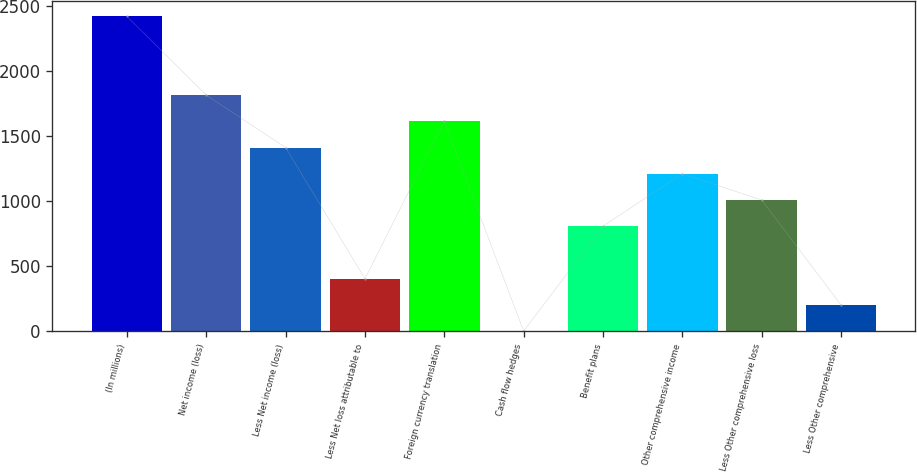Convert chart. <chart><loc_0><loc_0><loc_500><loc_500><bar_chart><fcel>(In millions)<fcel>Net income (loss)<fcel>Less Net income (loss)<fcel>Less Net loss attributable to<fcel>Foreign currency translation<fcel>Cash flow hedges<fcel>Benefit plans<fcel>Other comprehensive income<fcel>Less Other comprehensive loss<fcel>Less Other comprehensive<nl><fcel>2417.6<fcel>1813.7<fcel>1411.1<fcel>404.6<fcel>1612.4<fcel>2<fcel>807.2<fcel>1209.8<fcel>1008.5<fcel>203.3<nl></chart> 